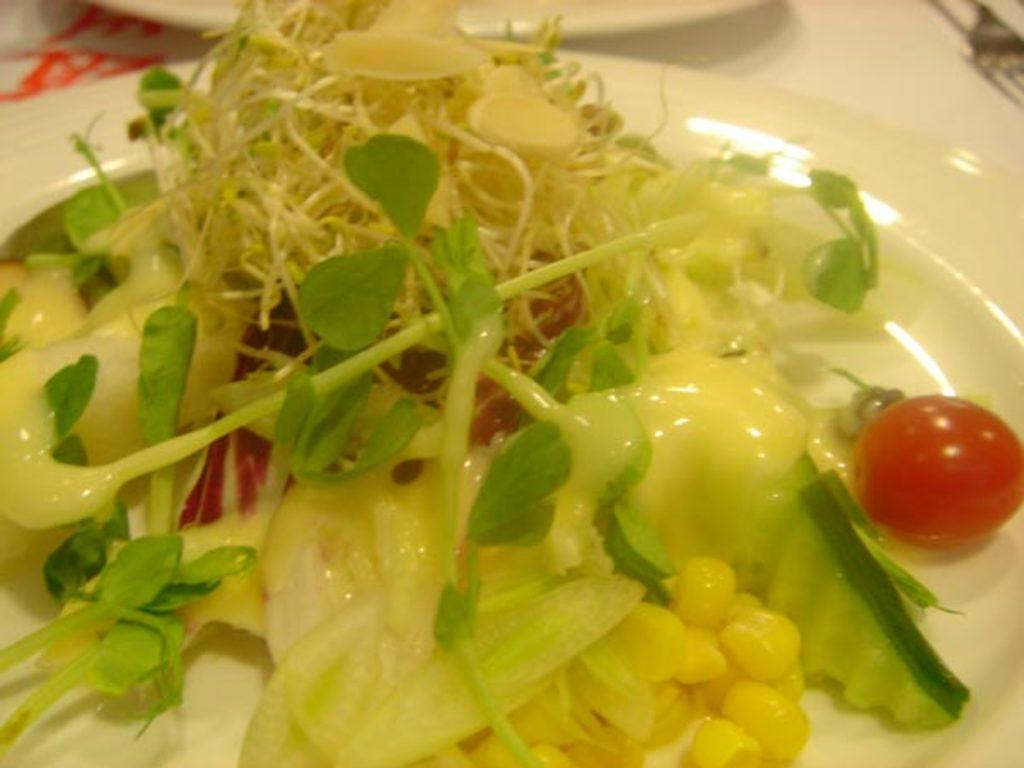What type of food is on the plate in the image? The plate of food contains corn, leafy vegetables, and cherries. What utensils are visible in the image? There are forks visible in the image. Are there any other plates on the table in the image? Yes, there is another plate on the table in the image. Can you smell the scent of the farm coming from the plate of food in the image? There is no mention of a farm or any scent in the image, so it cannot be determined if there is a scent coming from the plate of food. 